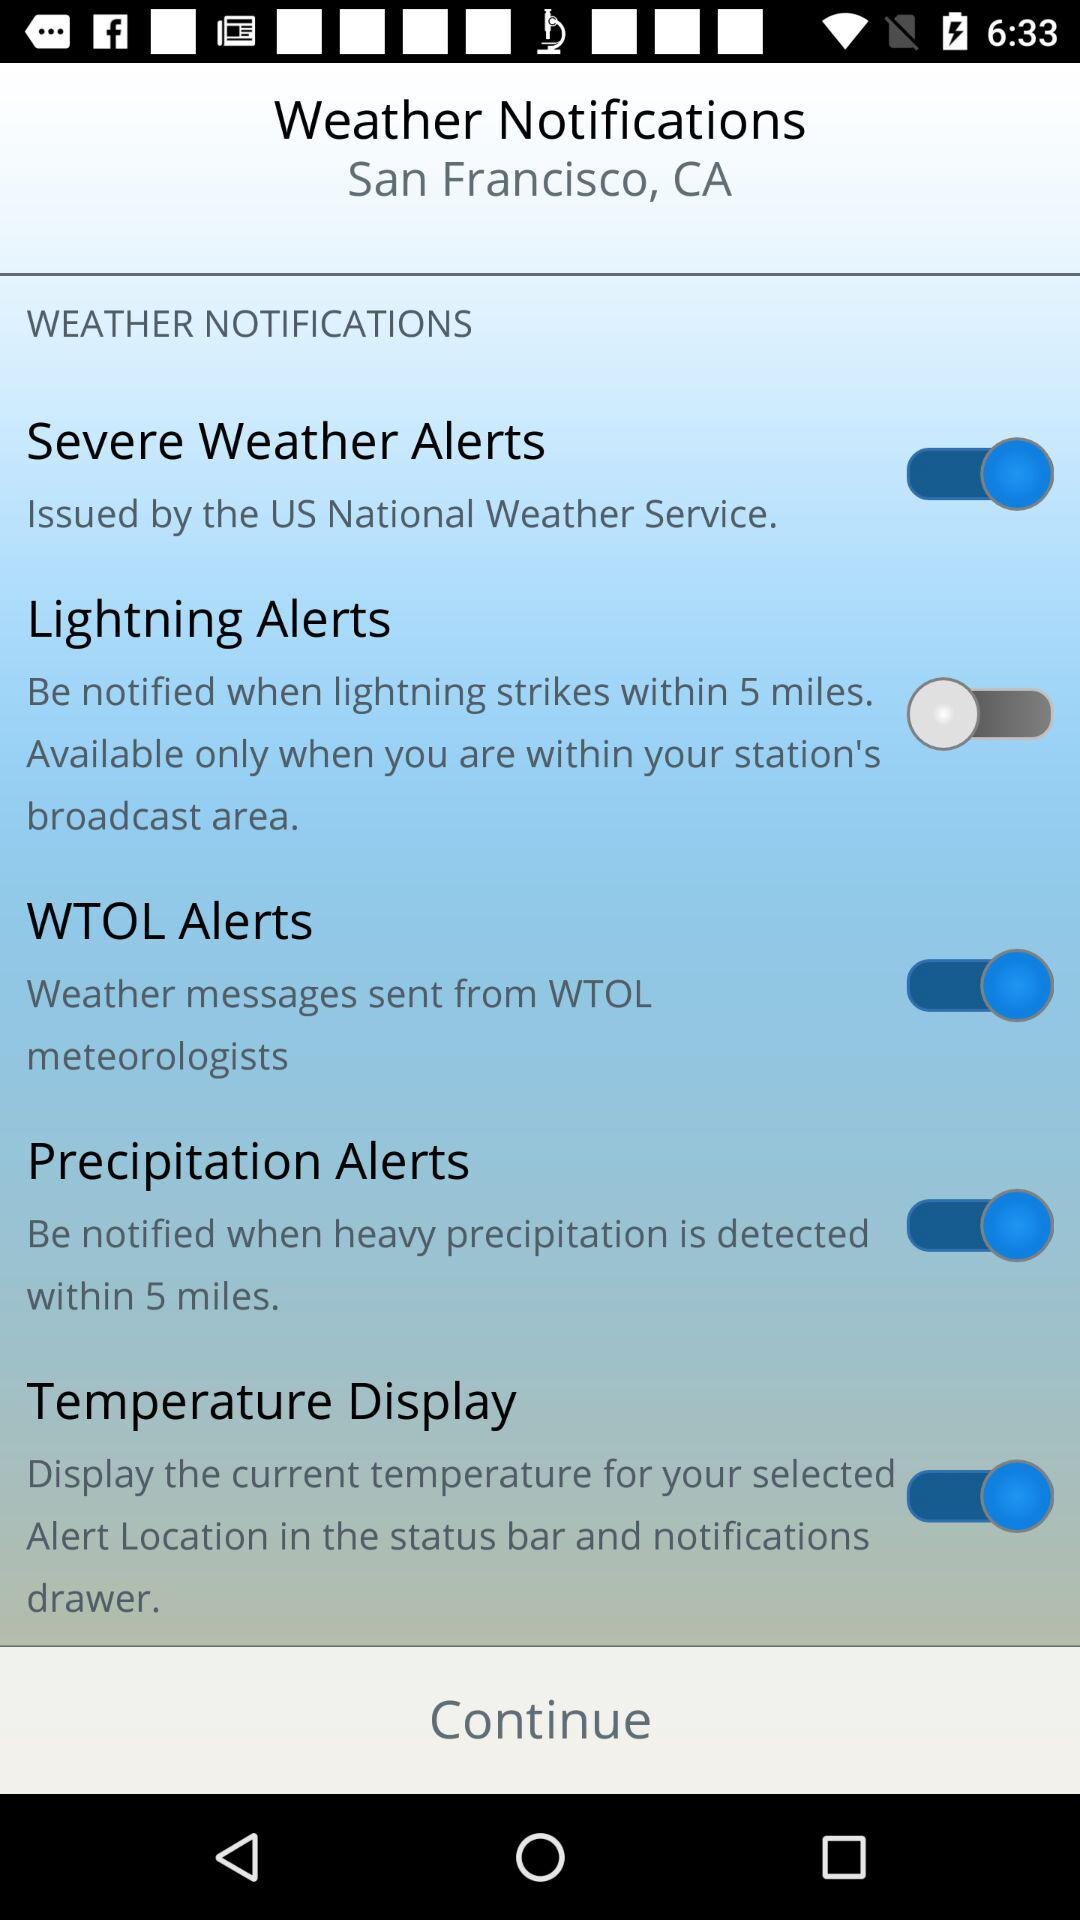How many weather alerts are available?
Answer the question using a single word or phrase. 4 